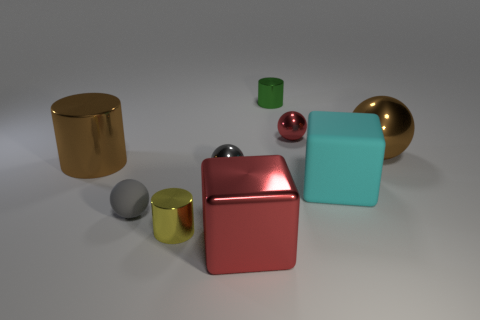Subtract all red spheres. How many spheres are left? 3 Subtract all small shiny cylinders. How many cylinders are left? 1 Subtract all green balls. Subtract all gray cylinders. How many balls are left? 4 Add 1 large brown objects. How many objects exist? 10 Subtract all cubes. How many objects are left? 7 Subtract all small metal spheres. Subtract all green things. How many objects are left? 6 Add 5 gray shiny objects. How many gray shiny objects are left? 6 Add 8 small metal cylinders. How many small metal cylinders exist? 10 Subtract 0 cyan cylinders. How many objects are left? 9 